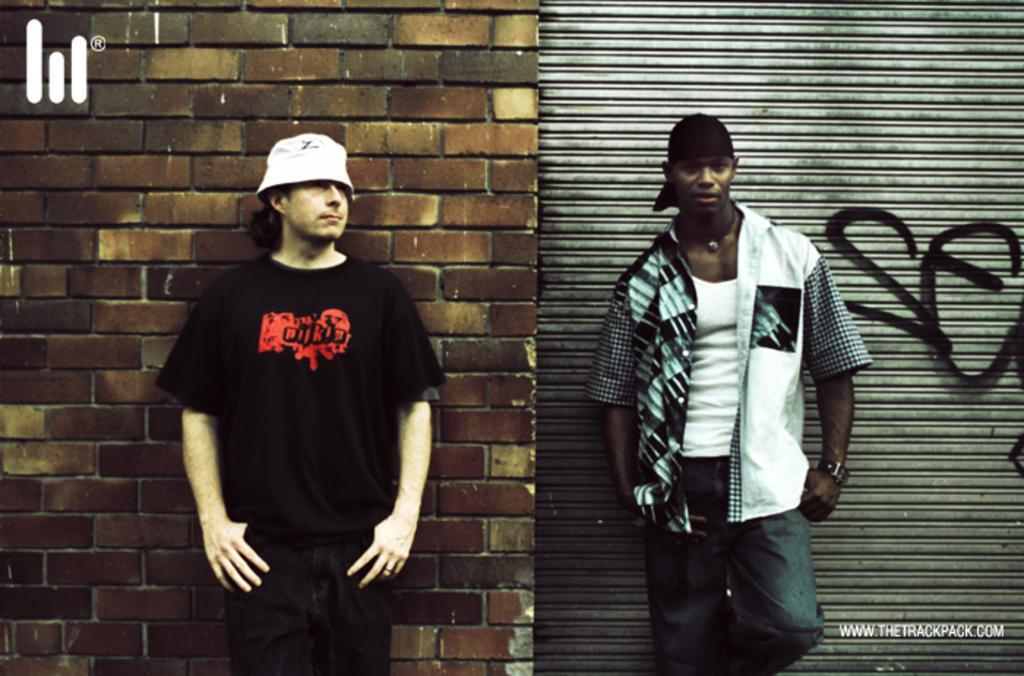How would you summarize this image in a sentence or two? In this picture we can see there are two men standing. Behind the men there is a wall and a roller shutter. On the image there are watermarks. 